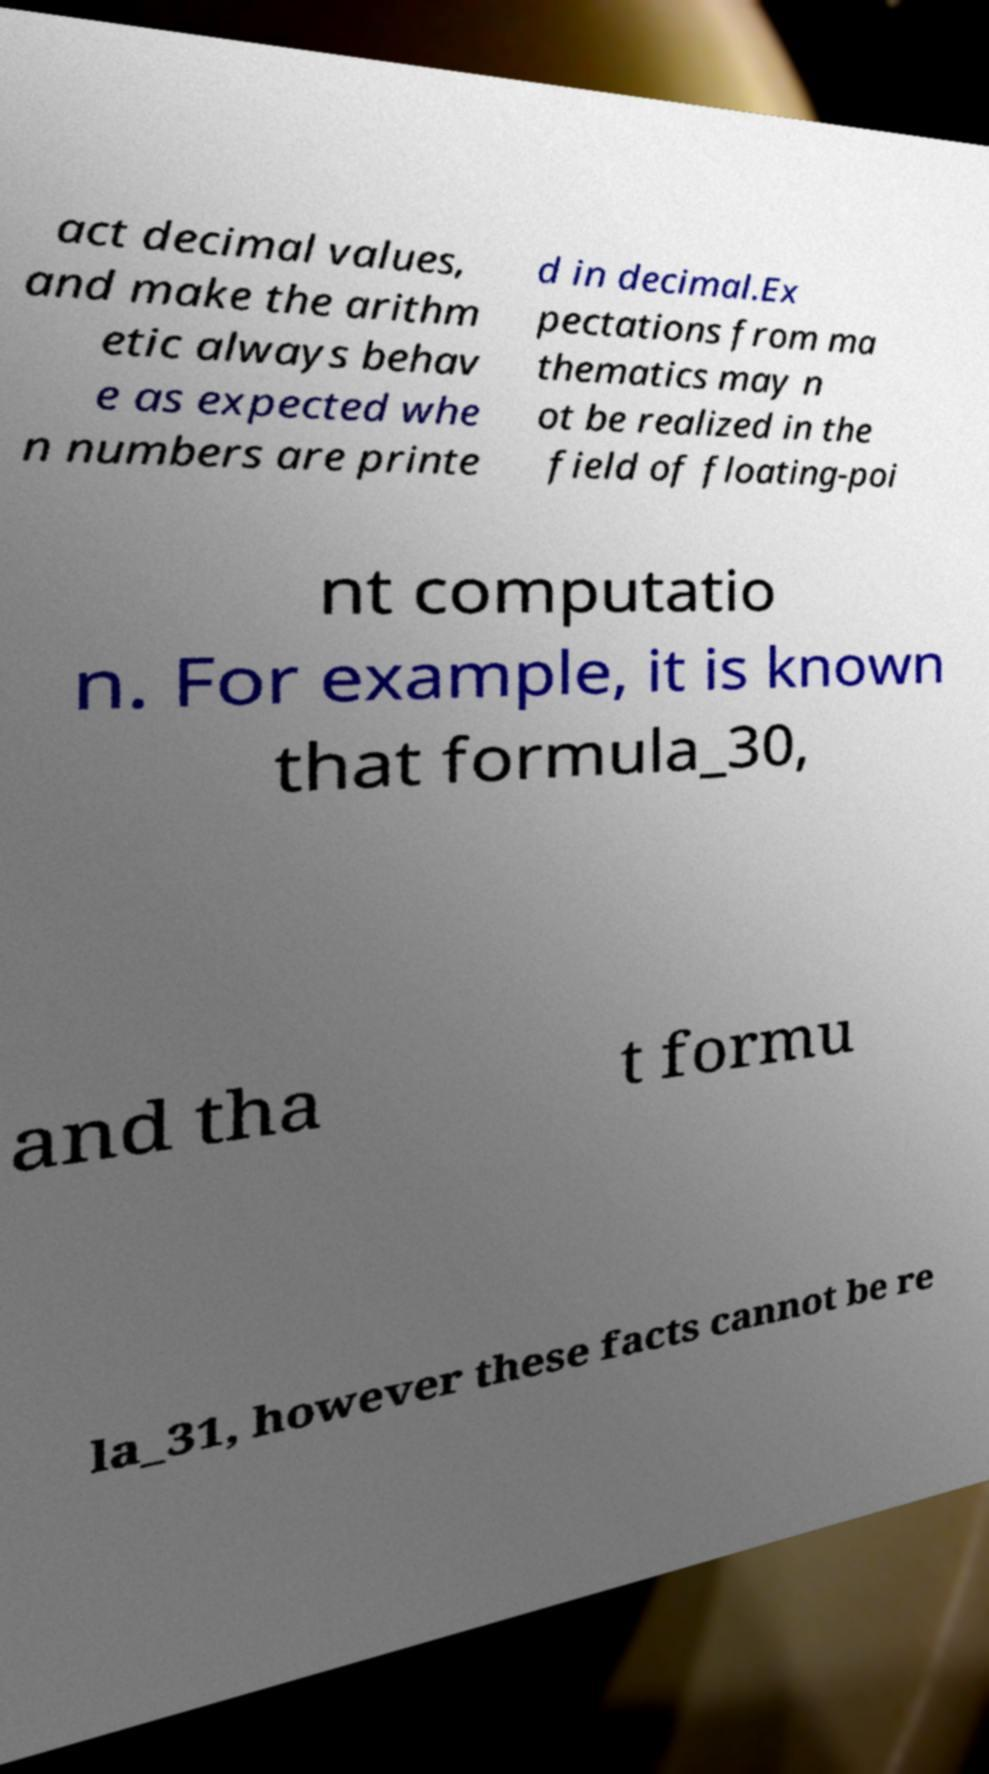For documentation purposes, I need the text within this image transcribed. Could you provide that? act decimal values, and make the arithm etic always behav e as expected whe n numbers are printe d in decimal.Ex pectations from ma thematics may n ot be realized in the field of floating-poi nt computatio n. For example, it is known that formula_30, and tha t formu la_31, however these facts cannot be re 